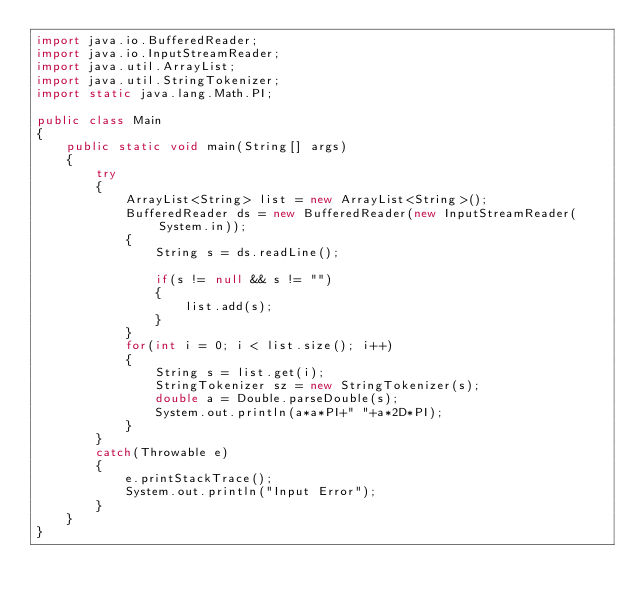Convert code to text. <code><loc_0><loc_0><loc_500><loc_500><_Java_>import java.io.BufferedReader;
import java.io.InputStreamReader;
import java.util.ArrayList;
import java.util.StringTokenizer;
import static java.lang.Math.PI;

public class Main
{
	public static void main(String[] args)
	{
		try
		{
			ArrayList<String> list = new ArrayList<String>();
			BufferedReader ds = new BufferedReader(new InputStreamReader(System.in));
			{
				String s = ds.readLine();

				if(s != null && s != "")
				{
					list.add(s);
				}
			}
			for(int i = 0; i < list.size(); i++)
			{
				String s = list.get(i);
				StringTokenizer sz = new StringTokenizer(s);
				double a = Double.parseDouble(s);
				System.out.println(a*a*PI+" "+a*2D*PI);
			}
		}
		catch(Throwable e)
		{
			e.printStackTrace();
			System.out.println("Input Error");
		}
	}
}</code> 